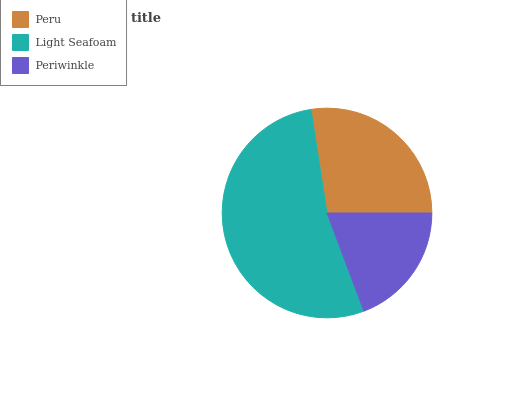Is Periwinkle the minimum?
Answer yes or no. Yes. Is Light Seafoam the maximum?
Answer yes or no. Yes. Is Light Seafoam the minimum?
Answer yes or no. No. Is Periwinkle the maximum?
Answer yes or no. No. Is Light Seafoam greater than Periwinkle?
Answer yes or no. Yes. Is Periwinkle less than Light Seafoam?
Answer yes or no. Yes. Is Periwinkle greater than Light Seafoam?
Answer yes or no. No. Is Light Seafoam less than Periwinkle?
Answer yes or no. No. Is Peru the high median?
Answer yes or no. Yes. Is Peru the low median?
Answer yes or no. Yes. Is Light Seafoam the high median?
Answer yes or no. No. Is Light Seafoam the low median?
Answer yes or no. No. 